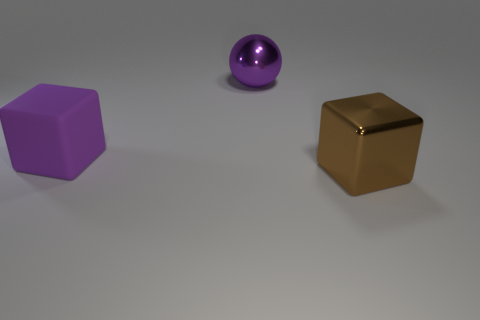Add 3 brown things. How many objects exist? 6 Subtract all spheres. How many objects are left? 2 Subtract 0 red spheres. How many objects are left? 3 Subtract all gray matte things. Subtract all metal blocks. How many objects are left? 2 Add 1 large purple cubes. How many large purple cubes are left? 2 Add 1 big purple things. How many big purple things exist? 3 